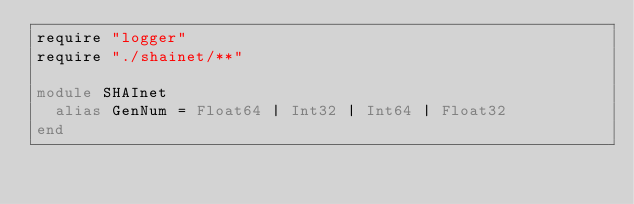Convert code to text. <code><loc_0><loc_0><loc_500><loc_500><_Crystal_>require "logger"
require "./shainet/**"

module SHAInet
  alias GenNum = Float64 | Int32 | Int64 | Float32
end
</code> 